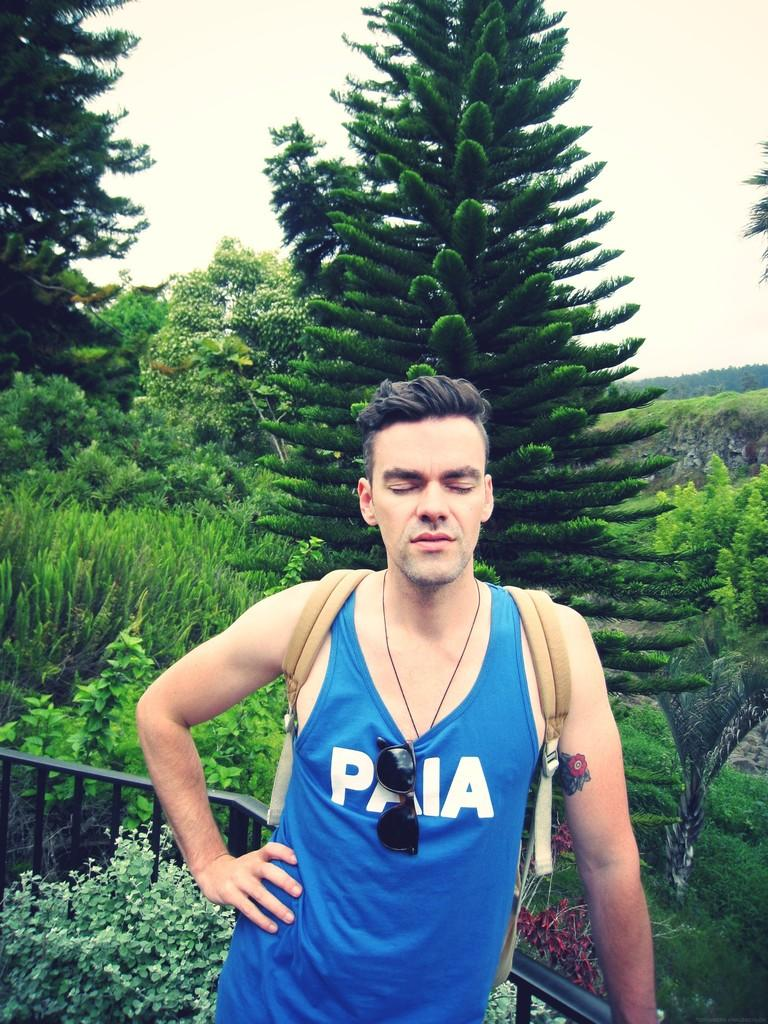Provide a one-sentence caption for the provided image. A man stands with eyes closed while wearing a blue shirt with the letters PAIA written across the front of it. 